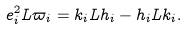Convert formula to latex. <formula><loc_0><loc_0><loc_500><loc_500>e _ { i } ^ { 2 } L \varpi _ { i } = k _ { i } L h _ { i } - h _ { i } L k _ { i } .</formula> 